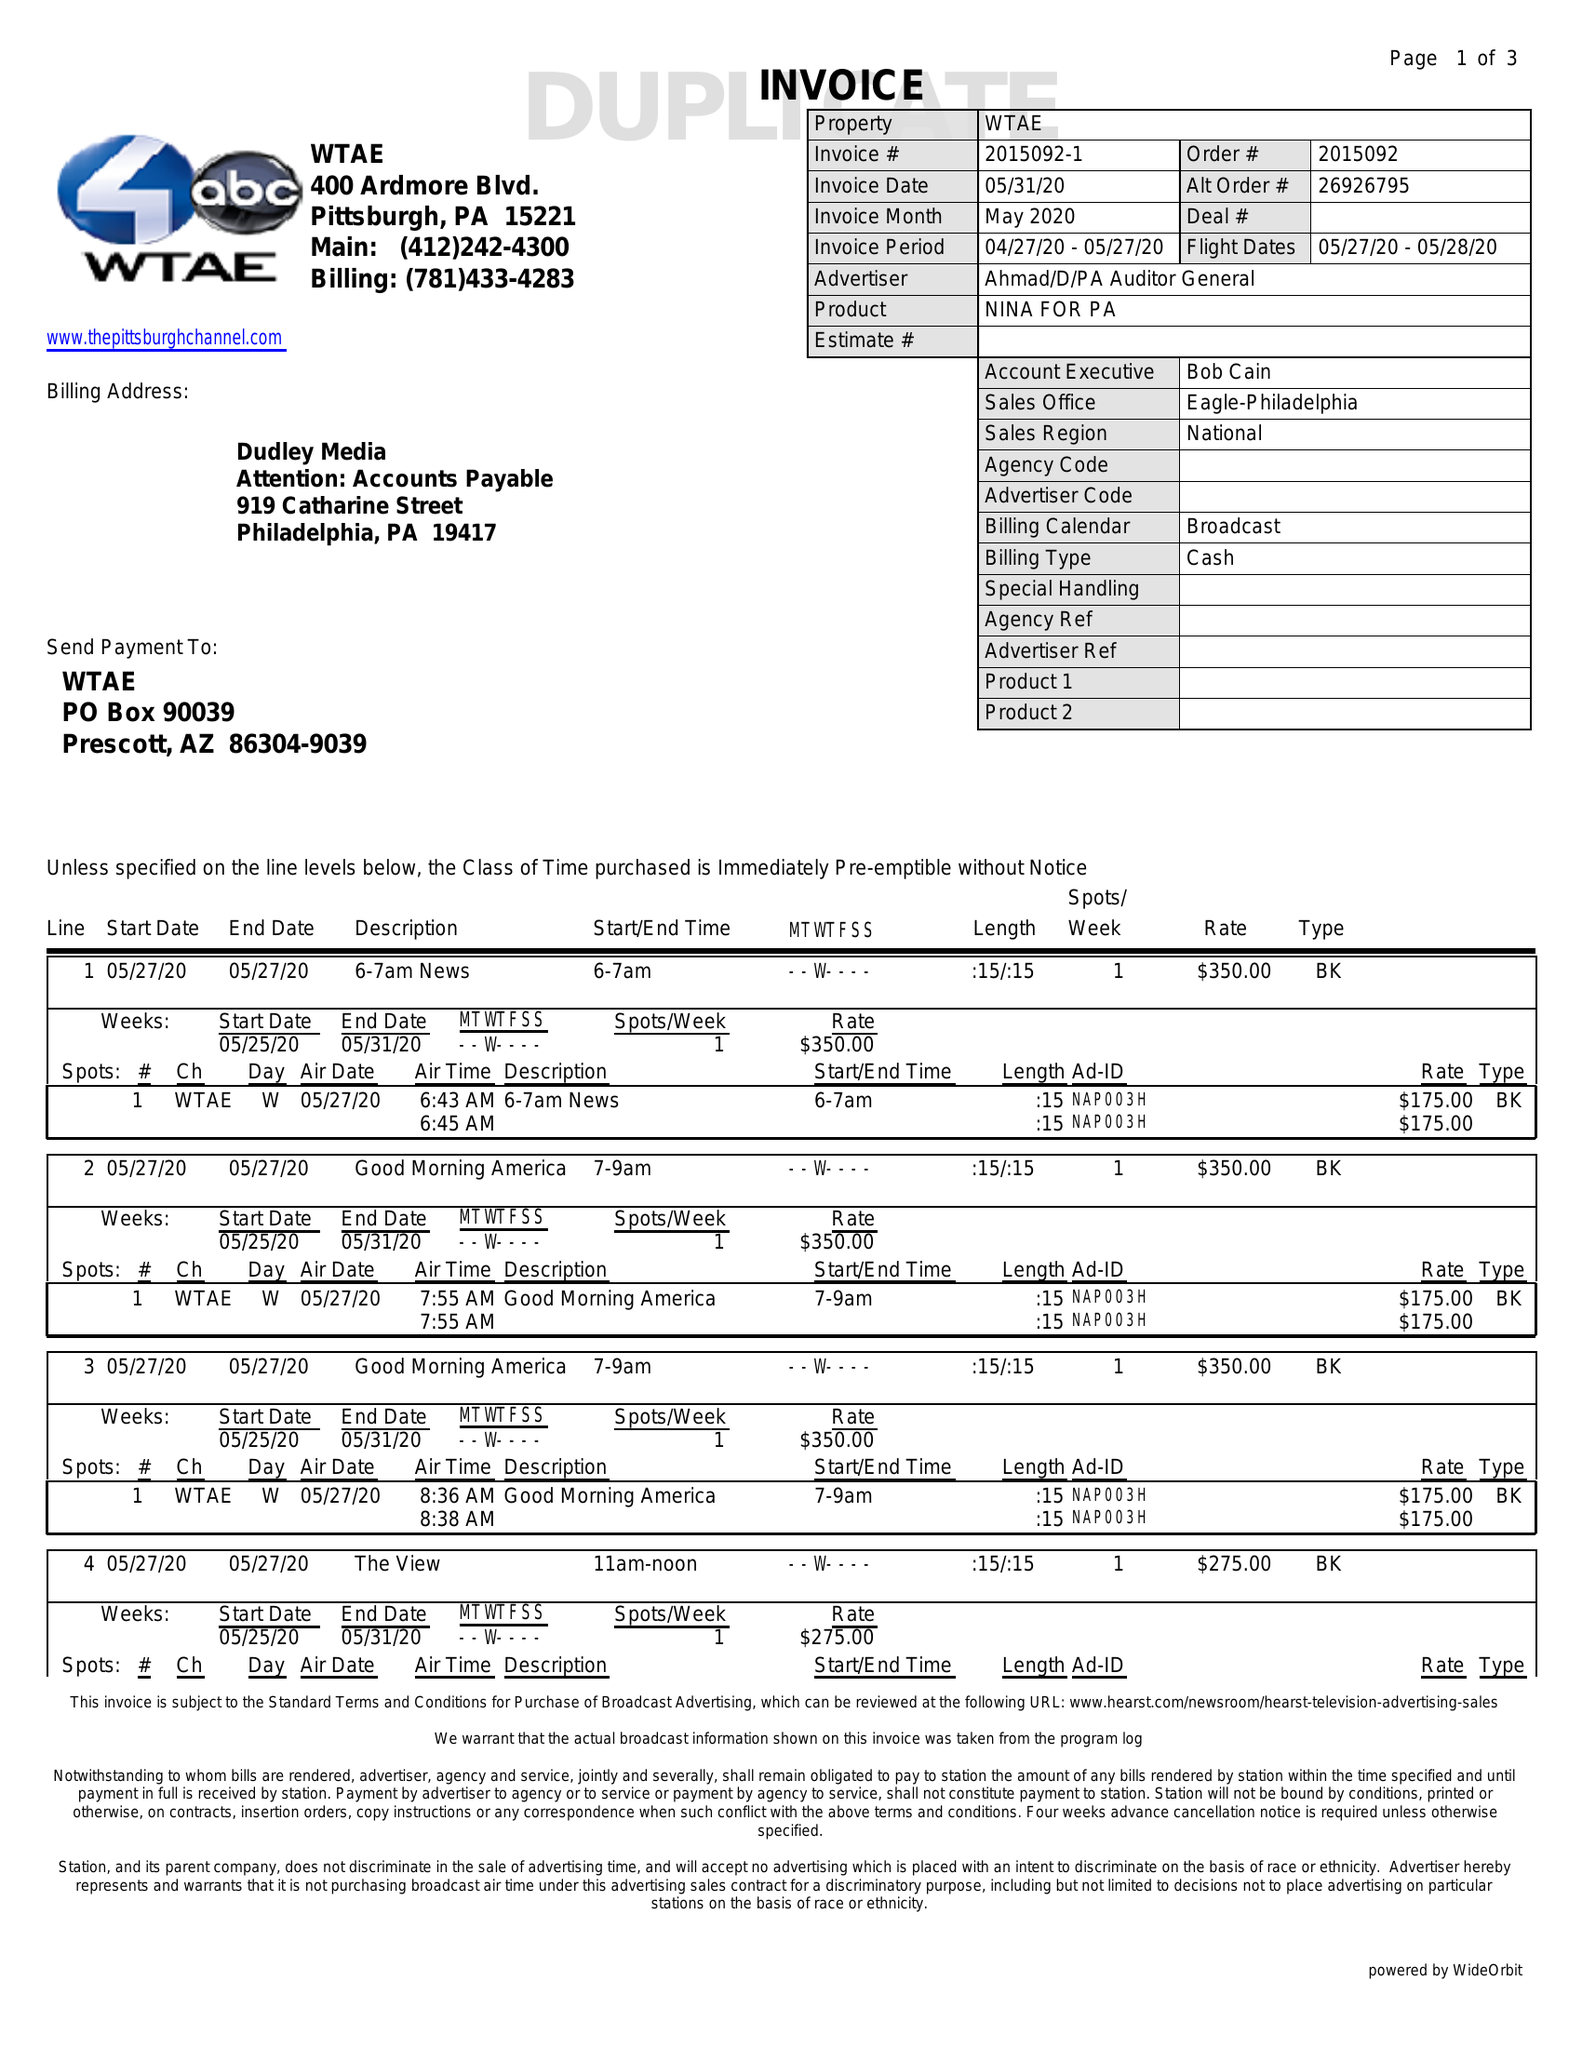What is the value for the contract_num?
Answer the question using a single word or phrase. 2015092 